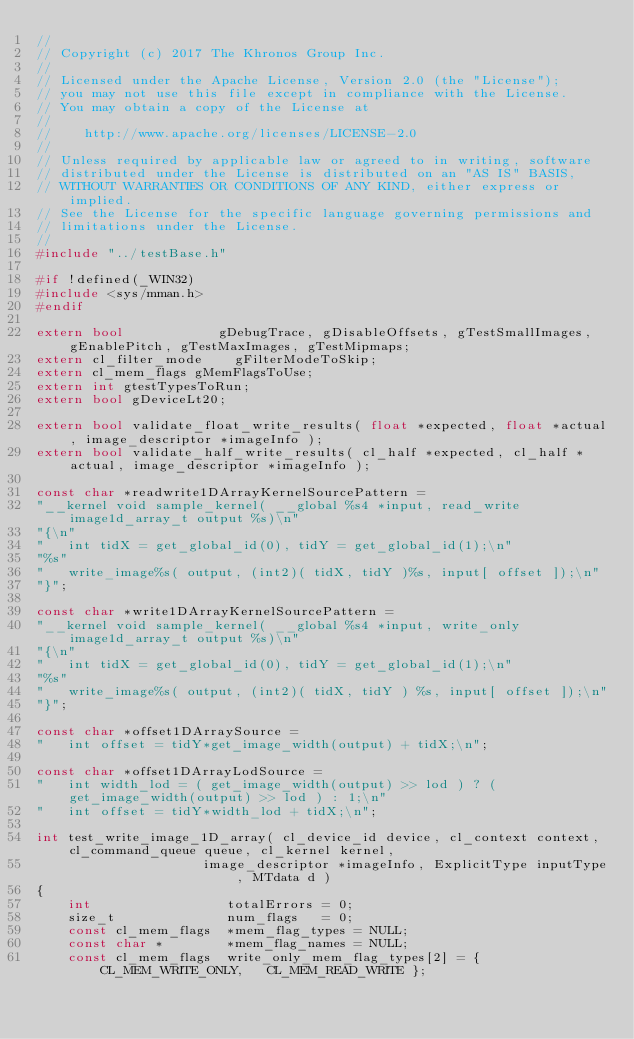<code> <loc_0><loc_0><loc_500><loc_500><_C++_>//
// Copyright (c) 2017 The Khronos Group Inc.
//
// Licensed under the Apache License, Version 2.0 (the "License");
// you may not use this file except in compliance with the License.
// You may obtain a copy of the License at
//
//    http://www.apache.org/licenses/LICENSE-2.0
//
// Unless required by applicable law or agreed to in writing, software
// distributed under the License is distributed on an "AS IS" BASIS,
// WITHOUT WARRANTIES OR CONDITIONS OF ANY KIND, either express or implied.
// See the License for the specific language governing permissions and
// limitations under the License.
//
#include "../testBase.h"

#if !defined(_WIN32)
#include <sys/mman.h>
#endif

extern bool            gDebugTrace, gDisableOffsets, gTestSmallImages, gEnablePitch, gTestMaxImages, gTestMipmaps;
extern cl_filter_mode    gFilterModeToSkip;
extern cl_mem_flags gMemFlagsToUse;
extern int gtestTypesToRun;
extern bool gDeviceLt20;

extern bool validate_float_write_results( float *expected, float *actual, image_descriptor *imageInfo );
extern bool validate_half_write_results( cl_half *expected, cl_half *actual, image_descriptor *imageInfo );

const char *readwrite1DArrayKernelSourcePattern =
"__kernel void sample_kernel( __global %s4 *input, read_write image1d_array_t output %s)\n"
"{\n"
"   int tidX = get_global_id(0), tidY = get_global_id(1);\n"
"%s"
"   write_image%s( output, (int2)( tidX, tidY )%s, input[ offset ]);\n"
"}";

const char *write1DArrayKernelSourcePattern =
"__kernel void sample_kernel( __global %s4 *input, write_only image1d_array_t output %s)\n"
"{\n"
"   int tidX = get_global_id(0), tidY = get_global_id(1);\n"
"%s"
"   write_image%s( output, (int2)( tidX, tidY ) %s, input[ offset ]);\n"
"}";

const char *offset1DArraySource =
"   int offset = tidY*get_image_width(output) + tidX;\n";

const char *offset1DArrayLodSource =
"   int width_lod = ( get_image_width(output) >> lod ) ? ( get_image_width(output) >> lod ) : 1;\n"
"   int offset = tidY*width_lod + tidX;\n";

int test_write_image_1D_array( cl_device_id device, cl_context context, cl_command_queue queue, cl_kernel kernel,
                     image_descriptor *imageInfo, ExplicitType inputType, MTdata d )
{
    int                 totalErrors = 0;
    size_t              num_flags   = 0;
    const cl_mem_flags  *mem_flag_types = NULL;
    const char *        *mem_flag_names = NULL;
    const cl_mem_flags  write_only_mem_flag_types[2] = {  CL_MEM_WRITE_ONLY,   CL_MEM_READ_WRITE };</code> 